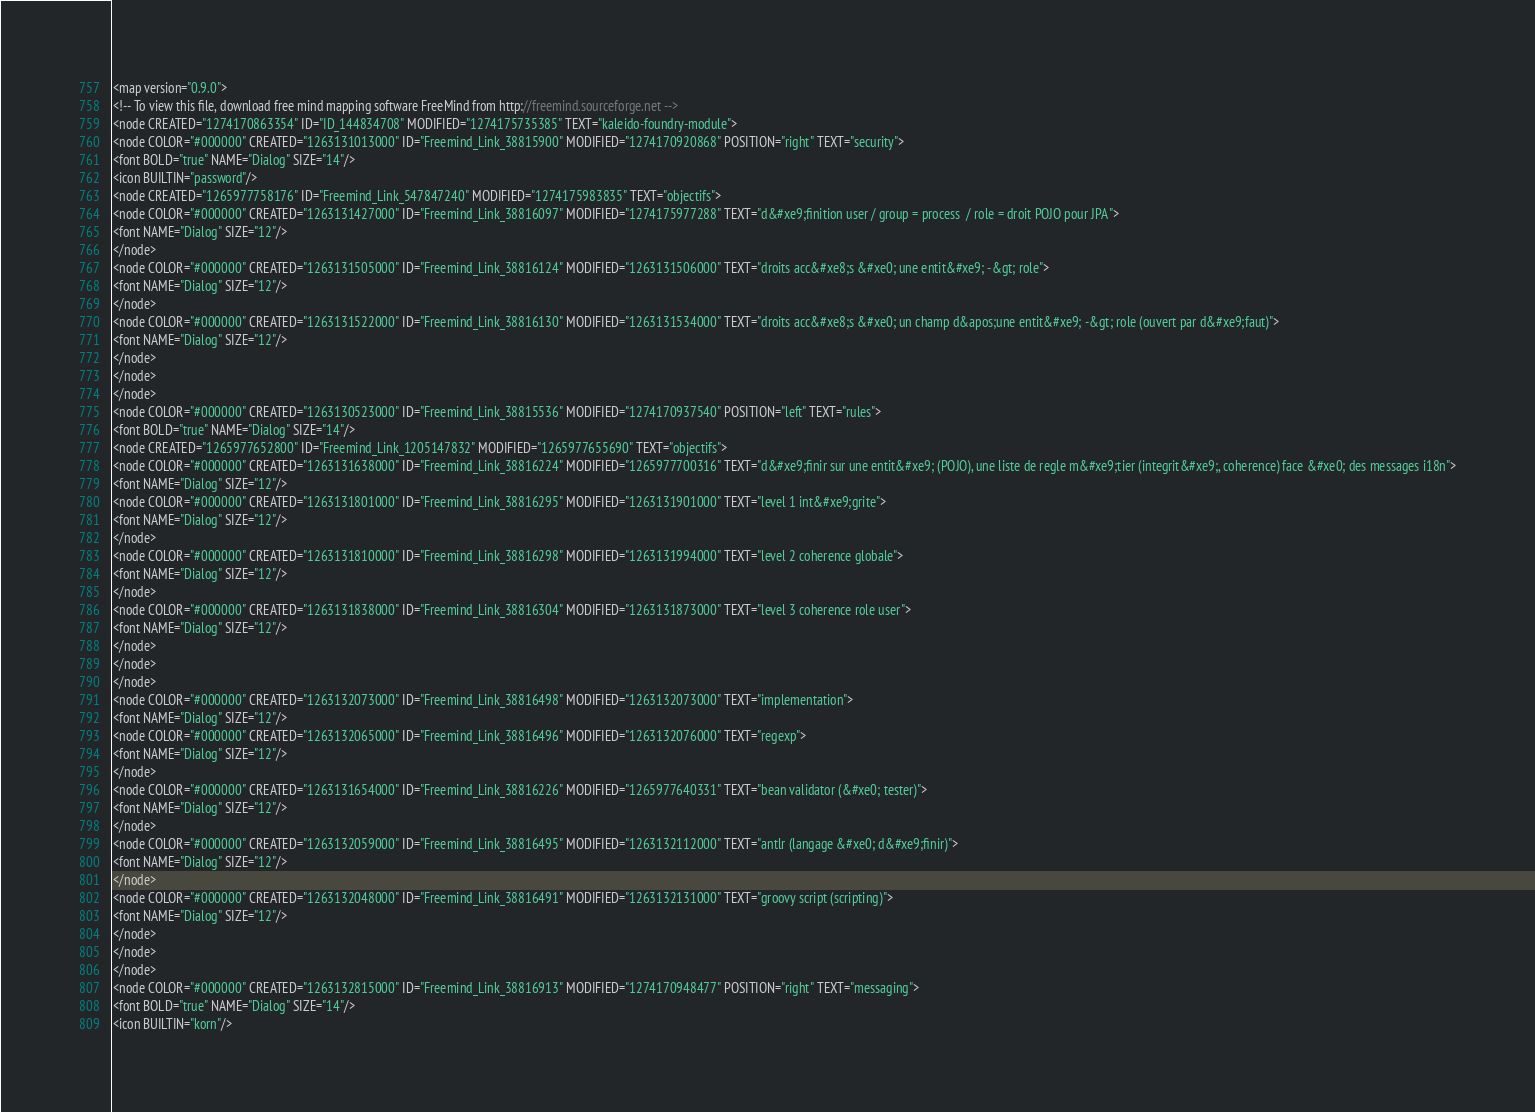Convert code to text. <code><loc_0><loc_0><loc_500><loc_500><_ObjectiveC_><map version="0.9.0">
<!-- To view this file, download free mind mapping software FreeMind from http://freemind.sourceforge.net -->
<node CREATED="1274170863354" ID="ID_144834708" MODIFIED="1274175735385" TEXT="kaleido-foundry-module">
<node COLOR="#000000" CREATED="1263131013000" ID="Freemind_Link_38815900" MODIFIED="1274170920868" POSITION="right" TEXT="security">
<font BOLD="true" NAME="Dialog" SIZE="14"/>
<icon BUILTIN="password"/>
<node CREATED="1265977758176" ID="Freemind_Link_547847240" MODIFIED="1274175983835" TEXT="objectifs">
<node COLOR="#000000" CREATED="1263131427000" ID="Freemind_Link_38816097" MODIFIED="1274175977288" TEXT="d&#xe9;finition user / group = process  / role = droit POJO pour JPA">
<font NAME="Dialog" SIZE="12"/>
</node>
<node COLOR="#000000" CREATED="1263131505000" ID="Freemind_Link_38816124" MODIFIED="1263131506000" TEXT="droits acc&#xe8;s &#xe0; une entit&#xe9; -&gt; role">
<font NAME="Dialog" SIZE="12"/>
</node>
<node COLOR="#000000" CREATED="1263131522000" ID="Freemind_Link_38816130" MODIFIED="1263131534000" TEXT="droits acc&#xe8;s &#xe0; un champ d&apos;une entit&#xe9; -&gt; role (ouvert par d&#xe9;faut)">
<font NAME="Dialog" SIZE="12"/>
</node>
</node>
</node>
<node COLOR="#000000" CREATED="1263130523000" ID="Freemind_Link_38815536" MODIFIED="1274170937540" POSITION="left" TEXT="rules">
<font BOLD="true" NAME="Dialog" SIZE="14"/>
<node CREATED="1265977652800" ID="Freemind_Link_1205147832" MODIFIED="1265977655690" TEXT="objectifs">
<node COLOR="#000000" CREATED="1263131638000" ID="Freemind_Link_38816224" MODIFIED="1265977700316" TEXT="d&#xe9;finir sur une entit&#xe9; (POJO), une liste de regle m&#xe9;tier (integrit&#xe9;, coherence) face &#xe0; des messages i18n">
<font NAME="Dialog" SIZE="12"/>
<node COLOR="#000000" CREATED="1263131801000" ID="Freemind_Link_38816295" MODIFIED="1263131901000" TEXT="level 1 int&#xe9;grite">
<font NAME="Dialog" SIZE="12"/>
</node>
<node COLOR="#000000" CREATED="1263131810000" ID="Freemind_Link_38816298" MODIFIED="1263131994000" TEXT="level 2 coherence globale">
<font NAME="Dialog" SIZE="12"/>
</node>
<node COLOR="#000000" CREATED="1263131838000" ID="Freemind_Link_38816304" MODIFIED="1263131873000" TEXT="level 3 coherence role user">
<font NAME="Dialog" SIZE="12"/>
</node>
</node>
</node>
<node COLOR="#000000" CREATED="1263132073000" ID="Freemind_Link_38816498" MODIFIED="1263132073000" TEXT="implementation">
<font NAME="Dialog" SIZE="12"/>
<node COLOR="#000000" CREATED="1263132065000" ID="Freemind_Link_38816496" MODIFIED="1263132076000" TEXT="regexp">
<font NAME="Dialog" SIZE="12"/>
</node>
<node COLOR="#000000" CREATED="1263131654000" ID="Freemind_Link_38816226" MODIFIED="1265977640331" TEXT="bean validator (&#xe0; tester)">
<font NAME="Dialog" SIZE="12"/>
</node>
<node COLOR="#000000" CREATED="1263132059000" ID="Freemind_Link_38816495" MODIFIED="1263132112000" TEXT="antlr (langage &#xe0; d&#xe9;finir)">
<font NAME="Dialog" SIZE="12"/>
</node>
<node COLOR="#000000" CREATED="1263132048000" ID="Freemind_Link_38816491" MODIFIED="1263132131000" TEXT="groovy script (scripting)">
<font NAME="Dialog" SIZE="12"/>
</node>
</node>
</node>
<node COLOR="#000000" CREATED="1263132815000" ID="Freemind_Link_38816913" MODIFIED="1274170948477" POSITION="right" TEXT="messaging">
<font BOLD="true" NAME="Dialog" SIZE="14"/>
<icon BUILTIN="korn"/></code> 